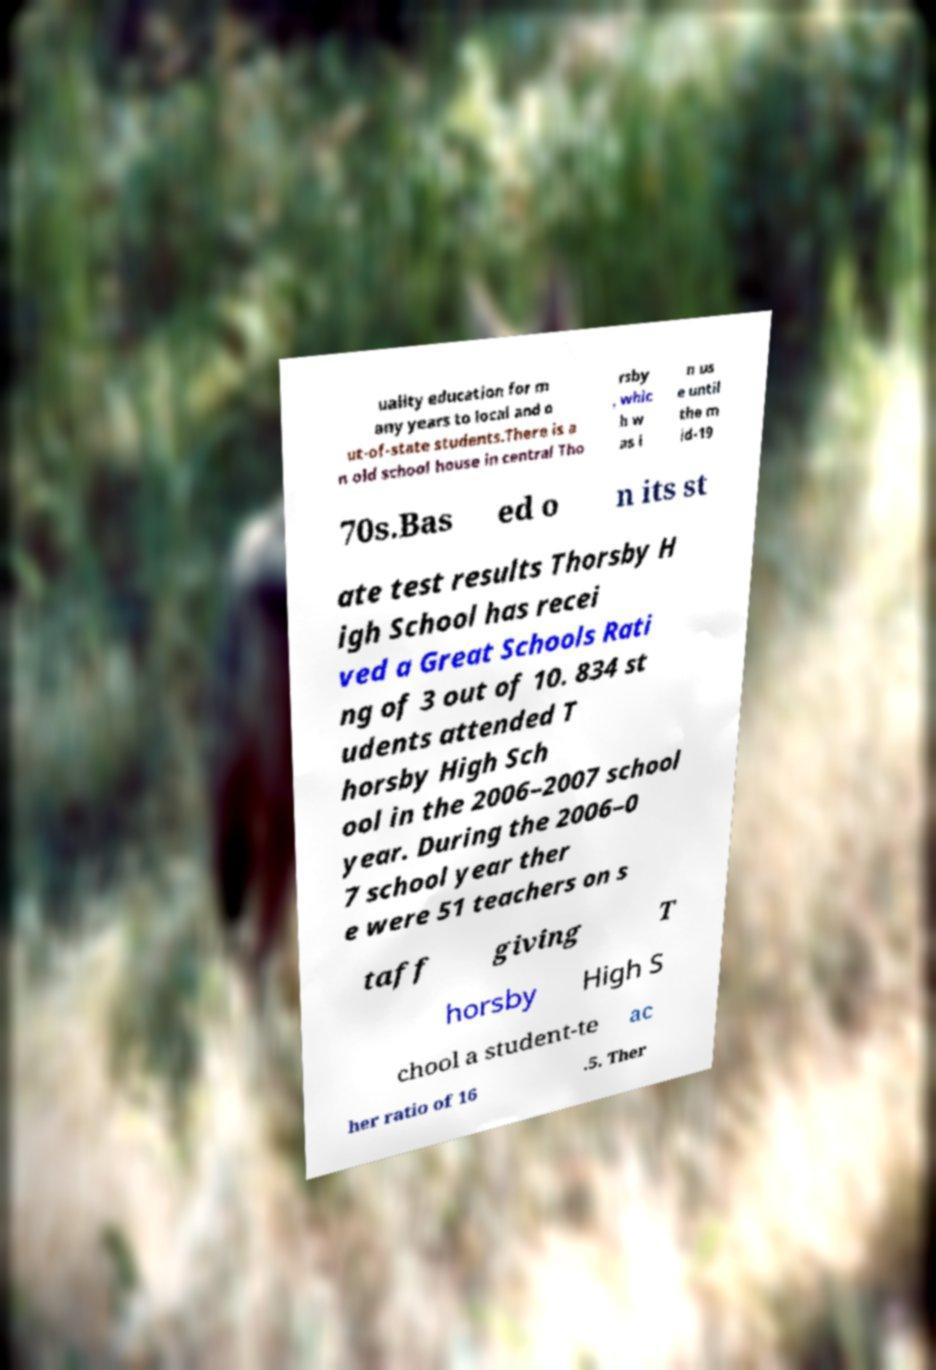What messages or text are displayed in this image? I need them in a readable, typed format. uality education for m any years to local and o ut-of-state students.There is a n old school house in central Tho rsby , whic h w as i n us e until the m id-19 70s.Bas ed o n its st ate test results Thorsby H igh School has recei ved a Great Schools Rati ng of 3 out of 10. 834 st udents attended T horsby High Sch ool in the 2006–2007 school year. During the 2006–0 7 school year ther e were 51 teachers on s taff giving T horsby High S chool a student-te ac her ratio of 16 .5. Ther 